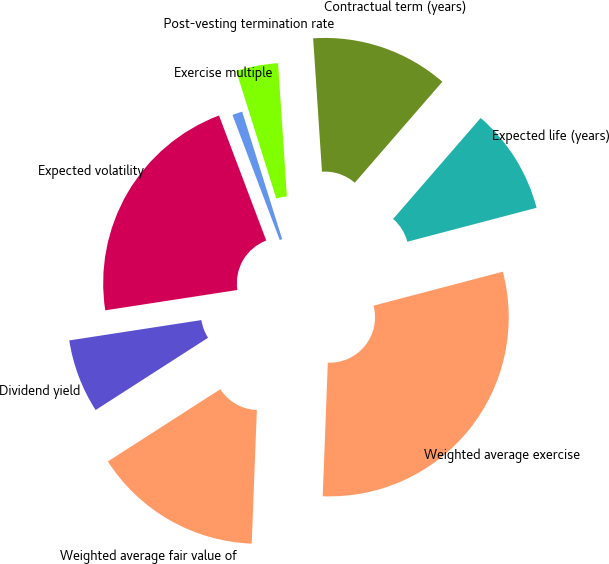<chart> <loc_0><loc_0><loc_500><loc_500><pie_chart><fcel>Dividend yield<fcel>Expected volatility<fcel>Exercise multiple<fcel>Post-vesting termination rate<fcel>Contractual term (years)<fcel>Expected life (years)<fcel>Weighted average exercise<fcel>Weighted average fair value of<nl><fcel>6.66%<fcel>21.68%<fcel>0.91%<fcel>3.79%<fcel>12.42%<fcel>9.54%<fcel>29.7%<fcel>15.3%<nl></chart> 